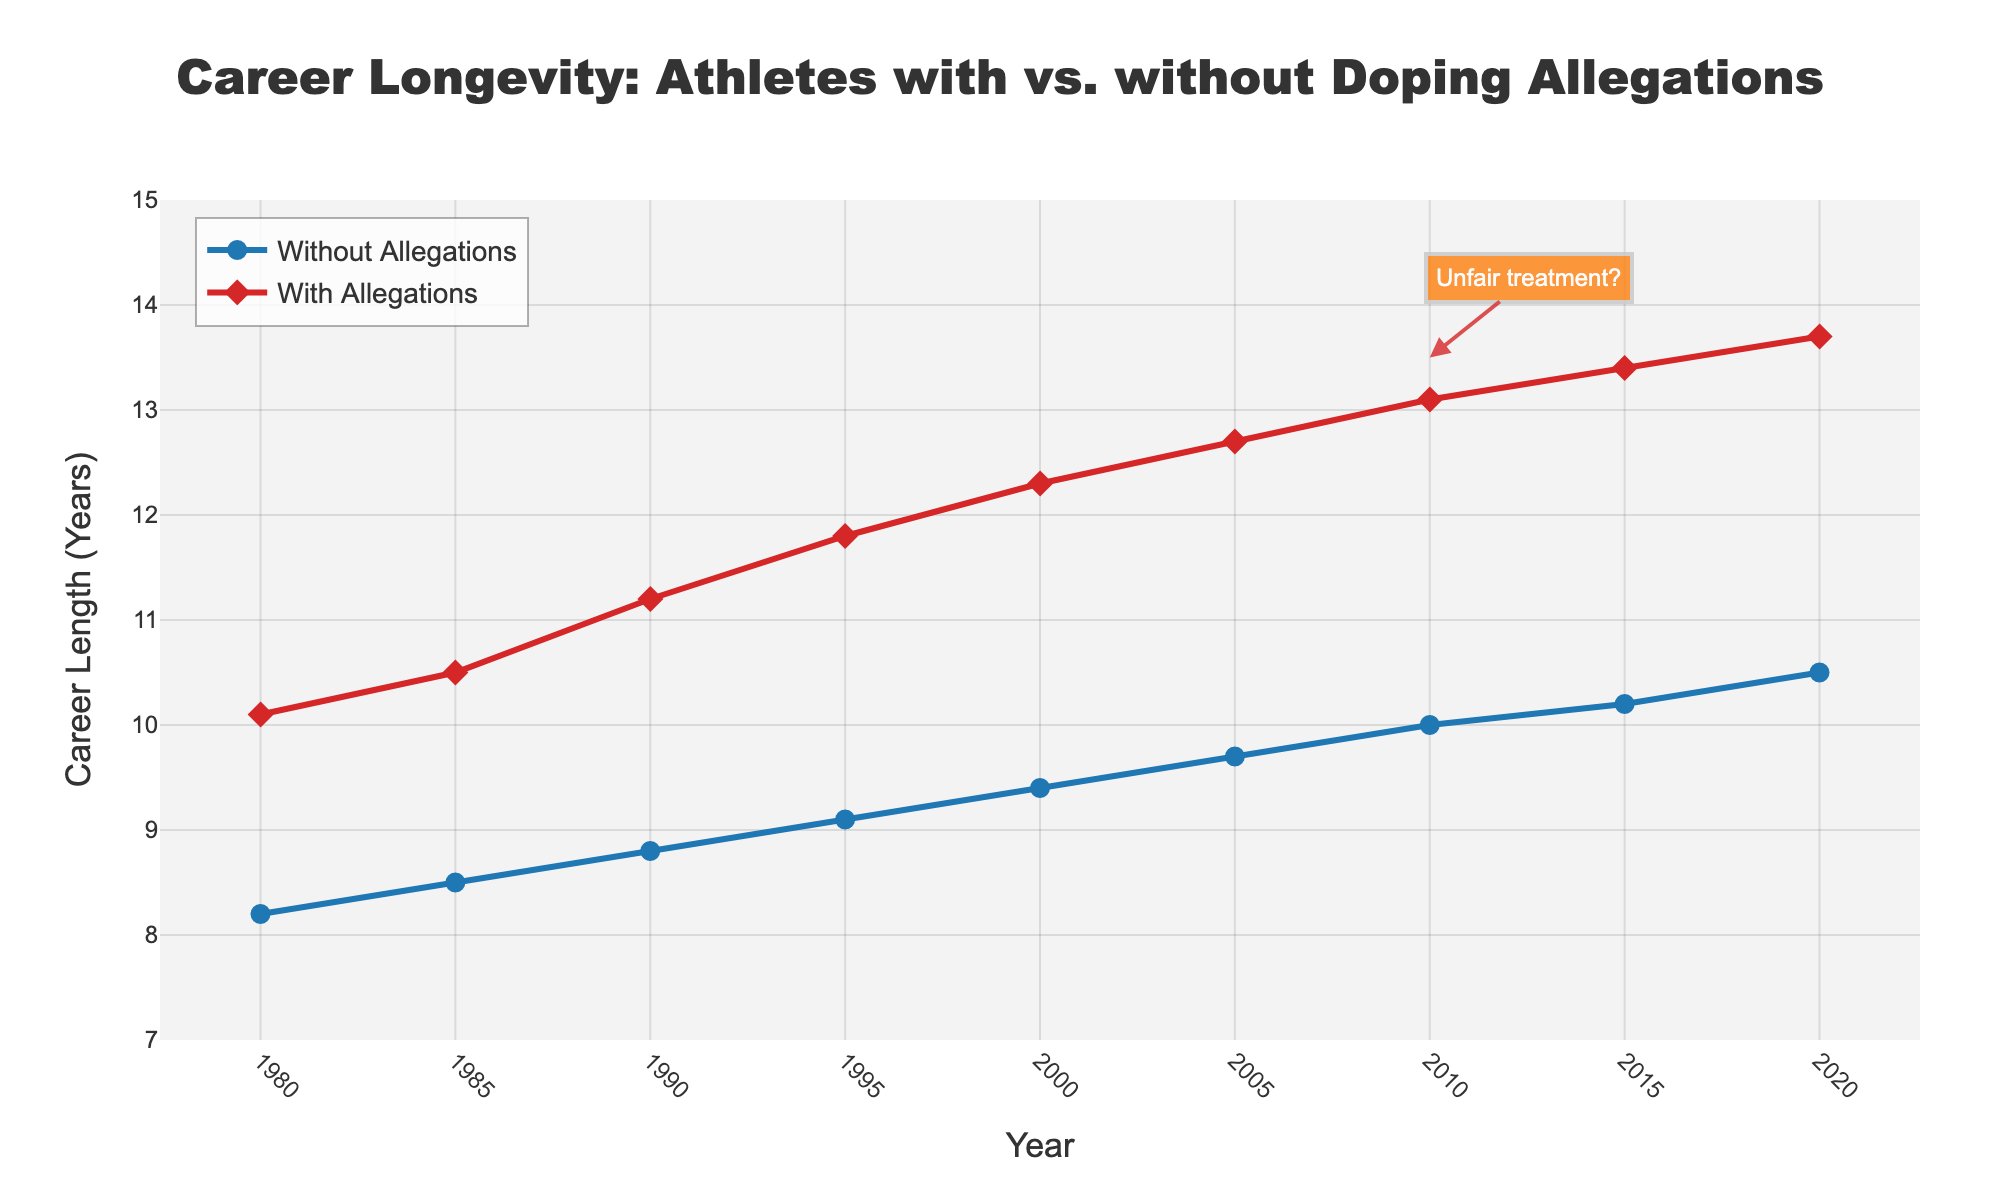What is the overall trend for both groups of athletes over time? The chart shows that both "Athletes without Allegations" and "Athletes with Allegations" experience an increase in career longevity over the years. By visually inspecting the slopes of both lines, we can observe a consistent upward trajectory from 1980 to 2020 for both groups.
Answer: Both groups show an upward trend in career longevity In which year is the career length difference between athletes with and without allegations the greatest? The chart indicates the career lengths for both groups from 1980 to 2020. By subtracting the career lengths for athletes without allegations from those with allegations for each year, we find the differences. The difference is greatest in the year 2020 (13.7 - 10.5 = 3.2 years).
Answer: 2020 Which group of athletes had a longer average career length during the period from 1980 to 2020? Summing the career lengths for each year for both groups, and then dividing by the number of years (9) gives the averages. Athletes without allegations: (8.2 + 8.5 + 8.8 + 9.1 + 9.4 + 9.7 + 10.0 + 10.2 + 10.5) / 9 = 9.27 years. Athletes with allegations: (10.1 + 10.5 + 11.2 + 11.8 + 12.3 + 12.7 + 13.1 + 13.4 + 13.7) / 9 = 11.53 years. Athletes with allegations had a longer average career length.
Answer: Athletes with allegations What is the color representing athletes with allegations on the chart? The chart uses specific colors to differentiate the two groups. The line and marker representing "Athletes with Allegations" is in red, as indicated by the visual representation in the chart's legend.
Answer: Red How has the career length of athletes without allegations changed from 1980 to 2020? By examining the line plot for athletes without allegations, the career lengths were 8.2 years in 1980 and increased to 10.5 years by 2020. This reveals a gradual increase over the 40-year period.
Answer: Increased from 8.2 to 10.5 years What is the value of the annotation, and where is it placed on the chart? The annotation "Unfair treatment?" is placed on the chart at the coordinates (x=2010, y=13.5). It aims to question the fairness concerning the career lengths of athletes with allegations being significantly longer.
Answer: "Unfair treatment?" at (2010, 13.5) Between which years did athletes with allegations see the most rapid increase in career length? To determine the most rapid increase, we calculate the differences in career lengths between consecutive years for athletes with allegations. The largest increase occurs between 1985 to 1990 (11.2 - 10.5 = 0.7 years).
Answer: 1985 to 1990 By what percentage has the career length of athletes without allegations increased from 1980 to 2020? Calculate the percentage increase using the formula: [(final value - initial value) / initial value] * 100. For athletes without allegations from 1980 (8.2 years) to 2020 (10.5 years): [(10.5 - 8.2) / 8.2] * 100 ≈ 28.05%.
Answer: Approximately 28.05% What visual attribute makes it easy to differentiate between the two groups in the chart? The line colors and marker shapes used for each group allow for easy differentiation: blue circles represent athletes without allegations, while red diamonds represent athletes with allegations.
Answer: Different colors and marker shapes Is there any year when athletes without allegations had a longer career length than athletes with allegations? By inspecting the chart, we can see that athletes without allegations consistently had shorter career lengths than those with allegations for every year from 1980 to 2020.
Answer: No 